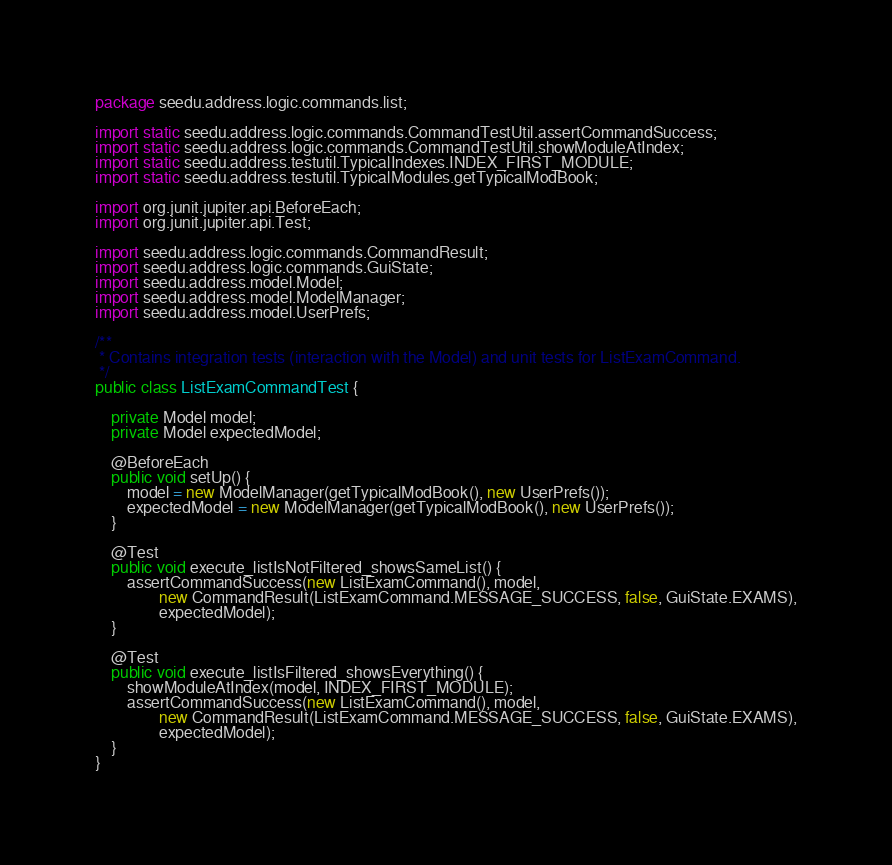Convert code to text. <code><loc_0><loc_0><loc_500><loc_500><_Java_>package seedu.address.logic.commands.list;

import static seedu.address.logic.commands.CommandTestUtil.assertCommandSuccess;
import static seedu.address.logic.commands.CommandTestUtil.showModuleAtIndex;
import static seedu.address.testutil.TypicalIndexes.INDEX_FIRST_MODULE;
import static seedu.address.testutil.TypicalModules.getTypicalModBook;

import org.junit.jupiter.api.BeforeEach;
import org.junit.jupiter.api.Test;

import seedu.address.logic.commands.CommandResult;
import seedu.address.logic.commands.GuiState;
import seedu.address.model.Model;
import seedu.address.model.ModelManager;
import seedu.address.model.UserPrefs;

/**
 * Contains integration tests (interaction with the Model) and unit tests for ListExamCommand.
 */
public class ListExamCommandTest {

    private Model model;
    private Model expectedModel;

    @BeforeEach
    public void setUp() {
        model = new ModelManager(getTypicalModBook(), new UserPrefs());
        expectedModel = new ModelManager(getTypicalModBook(), new UserPrefs());
    }

    @Test
    public void execute_listIsNotFiltered_showsSameList() {
        assertCommandSuccess(new ListExamCommand(), model,
                new CommandResult(ListExamCommand.MESSAGE_SUCCESS, false, GuiState.EXAMS),
                expectedModel);
    }

    @Test
    public void execute_listIsFiltered_showsEverything() {
        showModuleAtIndex(model, INDEX_FIRST_MODULE);
        assertCommandSuccess(new ListExamCommand(), model,
                new CommandResult(ListExamCommand.MESSAGE_SUCCESS, false, GuiState.EXAMS),
                expectedModel);
    }
}
</code> 